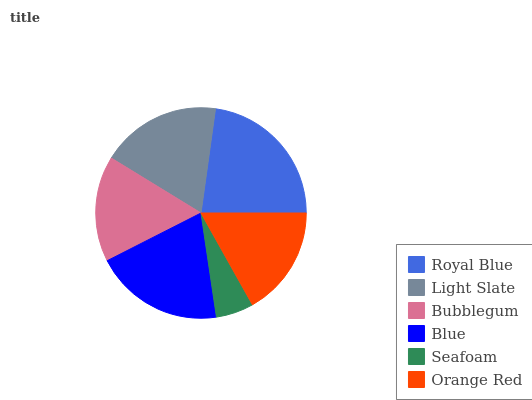Is Seafoam the minimum?
Answer yes or no. Yes. Is Royal Blue the maximum?
Answer yes or no. Yes. Is Light Slate the minimum?
Answer yes or no. No. Is Light Slate the maximum?
Answer yes or no. No. Is Royal Blue greater than Light Slate?
Answer yes or no. Yes. Is Light Slate less than Royal Blue?
Answer yes or no. Yes. Is Light Slate greater than Royal Blue?
Answer yes or no. No. Is Royal Blue less than Light Slate?
Answer yes or no. No. Is Light Slate the high median?
Answer yes or no. Yes. Is Orange Red the low median?
Answer yes or no. Yes. Is Royal Blue the high median?
Answer yes or no. No. Is Bubblegum the low median?
Answer yes or no. No. 